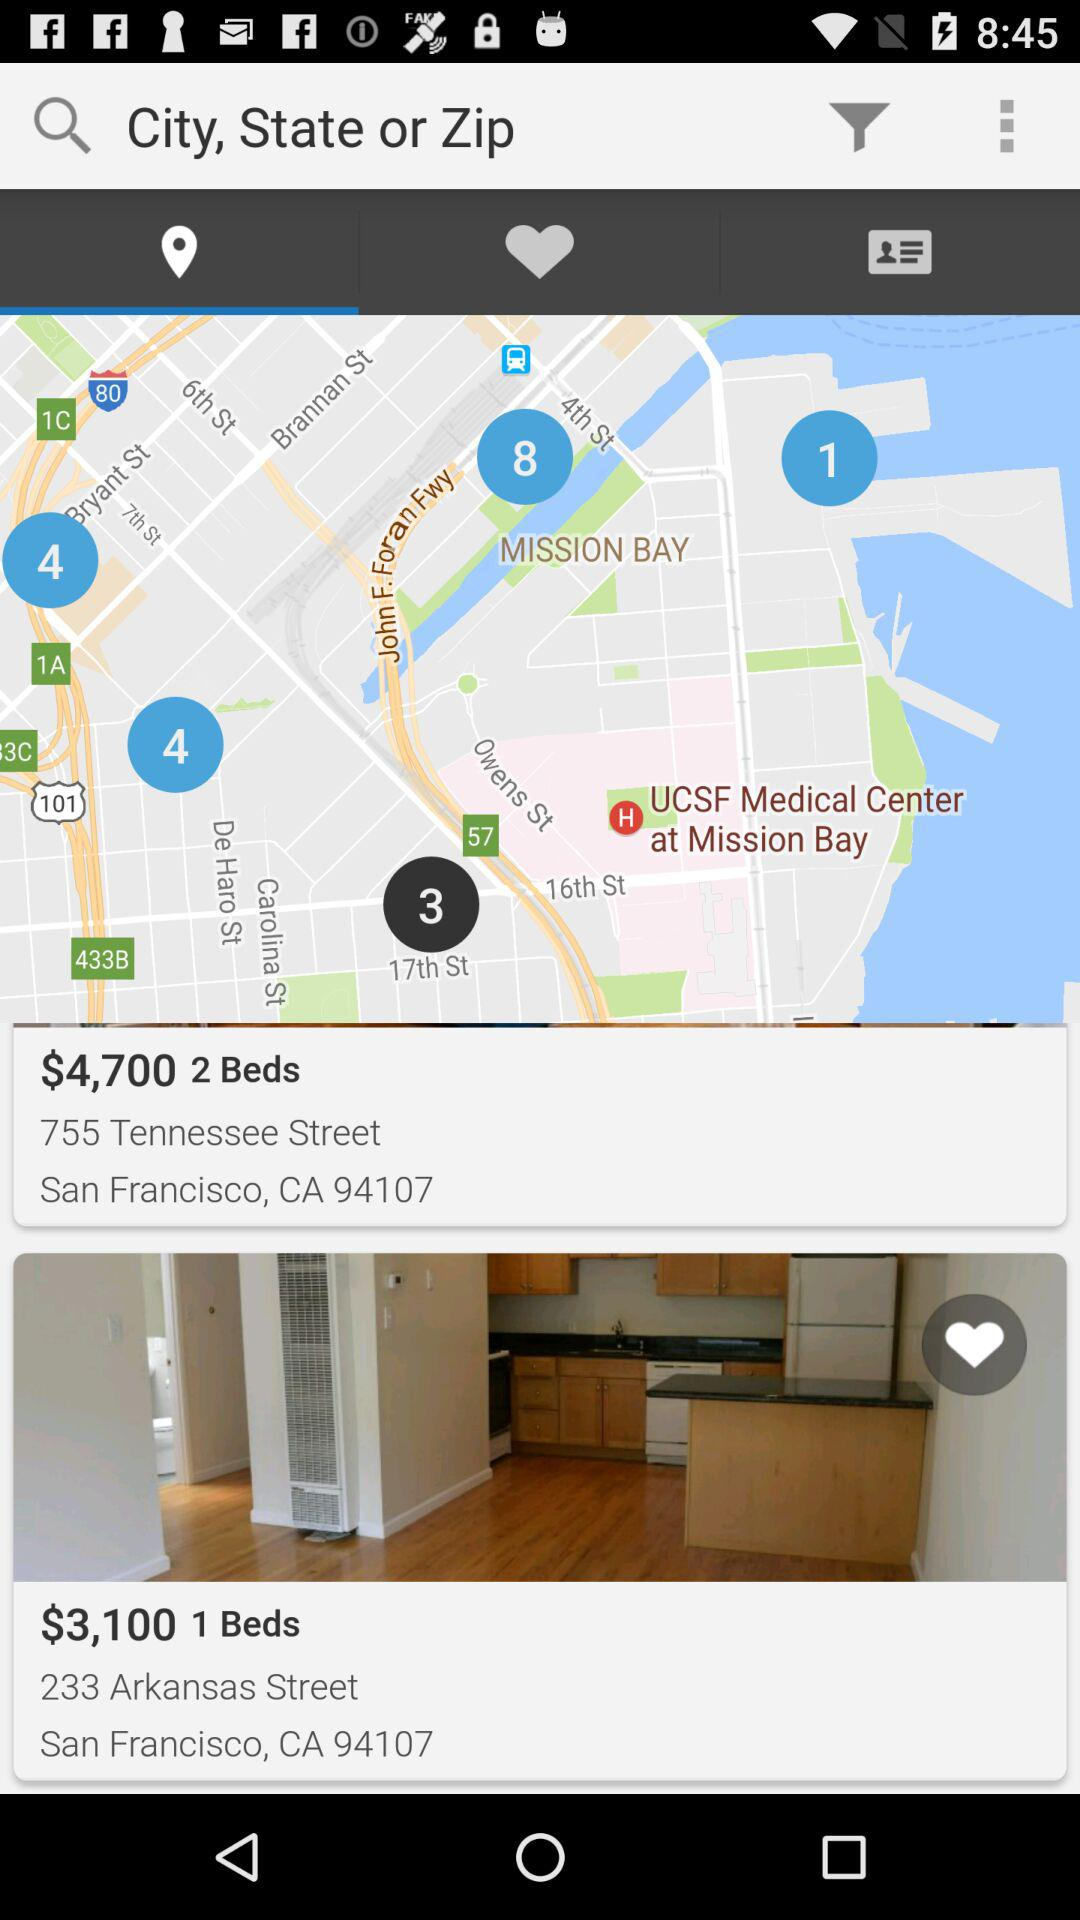What is the price of the apartment with two beds at 755 Tennessee Street? The price is $4,700. 